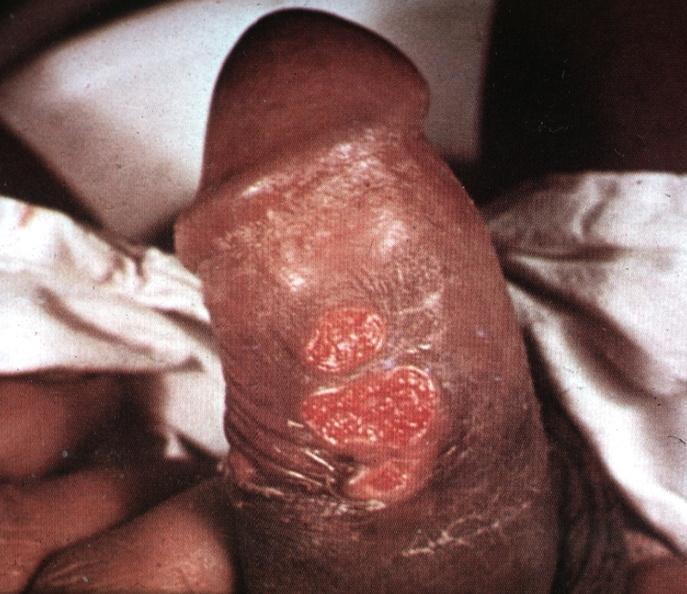s ulcerative lesions slide labeled chancroid?
Answer the question using a single word or phrase. Yes 